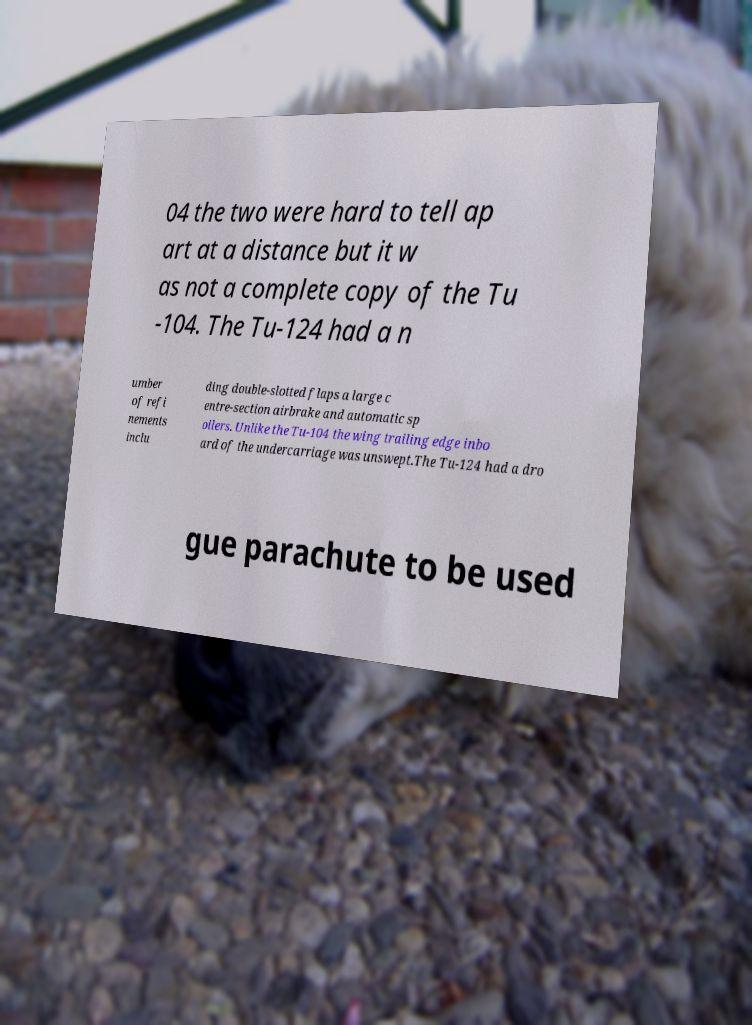Could you assist in decoding the text presented in this image and type it out clearly? 04 the two were hard to tell ap art at a distance but it w as not a complete copy of the Tu -104. The Tu-124 had a n umber of refi nements inclu ding double-slotted flaps a large c entre-section airbrake and automatic sp oilers. Unlike the Tu-104 the wing trailing edge inbo ard of the undercarriage was unswept.The Tu-124 had a dro gue parachute to be used 